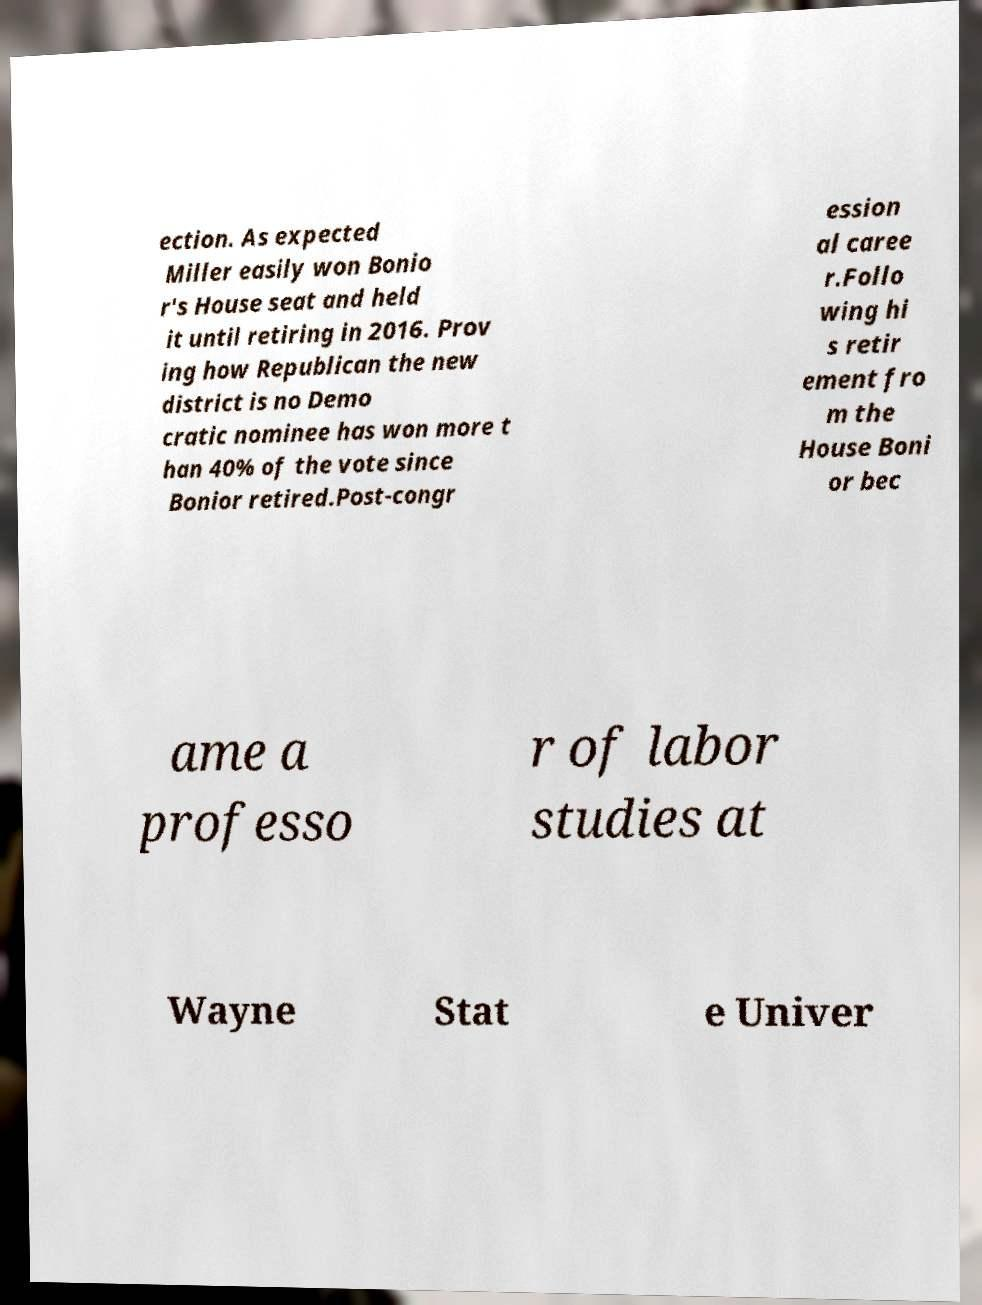Could you extract and type out the text from this image? ection. As expected Miller easily won Bonio r's House seat and held it until retiring in 2016. Prov ing how Republican the new district is no Demo cratic nominee has won more t han 40% of the vote since Bonior retired.Post-congr ession al caree r.Follo wing hi s retir ement fro m the House Boni or bec ame a professo r of labor studies at Wayne Stat e Univer 